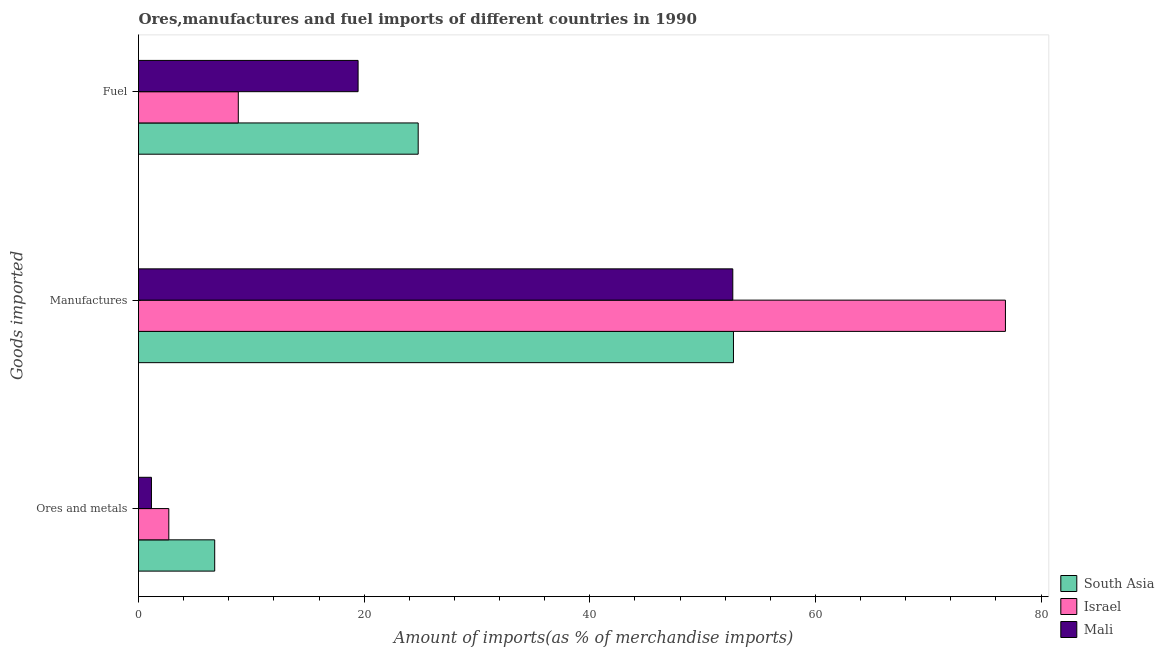How many different coloured bars are there?
Offer a terse response. 3. Are the number of bars on each tick of the Y-axis equal?
Provide a short and direct response. Yes. How many bars are there on the 1st tick from the top?
Your answer should be very brief. 3. What is the label of the 2nd group of bars from the top?
Provide a short and direct response. Manufactures. What is the percentage of manufactures imports in Israel?
Keep it short and to the point. 76.84. Across all countries, what is the maximum percentage of ores and metals imports?
Keep it short and to the point. 6.75. Across all countries, what is the minimum percentage of ores and metals imports?
Keep it short and to the point. 1.15. In which country was the percentage of ores and metals imports maximum?
Ensure brevity in your answer.  South Asia. What is the total percentage of ores and metals imports in the graph?
Give a very brief answer. 10.59. What is the difference between the percentage of manufactures imports in Mali and that in Israel?
Ensure brevity in your answer.  -24.17. What is the difference between the percentage of fuel imports in Mali and the percentage of manufactures imports in Israel?
Provide a short and direct response. -57.38. What is the average percentage of manufactures imports per country?
Your answer should be compact. 60.75. What is the difference between the percentage of ores and metals imports and percentage of manufactures imports in South Asia?
Your response must be concise. -45.98. What is the ratio of the percentage of fuel imports in Mali to that in Israel?
Give a very brief answer. 2.2. Is the percentage of manufactures imports in Mali less than that in South Asia?
Make the answer very short. Yes. What is the difference between the highest and the second highest percentage of ores and metals imports?
Your response must be concise. 4.07. What is the difference between the highest and the lowest percentage of ores and metals imports?
Your answer should be very brief. 5.61. In how many countries, is the percentage of fuel imports greater than the average percentage of fuel imports taken over all countries?
Provide a succinct answer. 2. What does the 1st bar from the bottom in Manufactures represents?
Ensure brevity in your answer.  South Asia. Is it the case that in every country, the sum of the percentage of ores and metals imports and percentage of manufactures imports is greater than the percentage of fuel imports?
Your answer should be compact. Yes. Are all the bars in the graph horizontal?
Make the answer very short. Yes. What is the difference between two consecutive major ticks on the X-axis?
Keep it short and to the point. 20. What is the title of the graph?
Offer a terse response. Ores,manufactures and fuel imports of different countries in 1990. What is the label or title of the X-axis?
Your answer should be compact. Amount of imports(as % of merchandise imports). What is the label or title of the Y-axis?
Provide a succinct answer. Goods imported. What is the Amount of imports(as % of merchandise imports) in South Asia in Ores and metals?
Make the answer very short. 6.75. What is the Amount of imports(as % of merchandise imports) of Israel in Ores and metals?
Your response must be concise. 2.69. What is the Amount of imports(as % of merchandise imports) in Mali in Ores and metals?
Provide a succinct answer. 1.15. What is the Amount of imports(as % of merchandise imports) in South Asia in Manufactures?
Give a very brief answer. 52.73. What is the Amount of imports(as % of merchandise imports) in Israel in Manufactures?
Give a very brief answer. 76.84. What is the Amount of imports(as % of merchandise imports) in Mali in Manufactures?
Give a very brief answer. 52.68. What is the Amount of imports(as % of merchandise imports) in South Asia in Fuel?
Give a very brief answer. 24.79. What is the Amount of imports(as % of merchandise imports) of Israel in Fuel?
Provide a short and direct response. 8.84. What is the Amount of imports(as % of merchandise imports) of Mali in Fuel?
Your answer should be compact. 19.46. Across all Goods imported, what is the maximum Amount of imports(as % of merchandise imports) of South Asia?
Keep it short and to the point. 52.73. Across all Goods imported, what is the maximum Amount of imports(as % of merchandise imports) in Israel?
Provide a succinct answer. 76.84. Across all Goods imported, what is the maximum Amount of imports(as % of merchandise imports) in Mali?
Your response must be concise. 52.68. Across all Goods imported, what is the minimum Amount of imports(as % of merchandise imports) of South Asia?
Your answer should be very brief. 6.75. Across all Goods imported, what is the minimum Amount of imports(as % of merchandise imports) in Israel?
Make the answer very short. 2.69. Across all Goods imported, what is the minimum Amount of imports(as % of merchandise imports) in Mali?
Your response must be concise. 1.15. What is the total Amount of imports(as % of merchandise imports) of South Asia in the graph?
Your response must be concise. 84.28. What is the total Amount of imports(as % of merchandise imports) in Israel in the graph?
Your response must be concise. 88.37. What is the total Amount of imports(as % of merchandise imports) in Mali in the graph?
Provide a succinct answer. 73.29. What is the difference between the Amount of imports(as % of merchandise imports) of South Asia in Ores and metals and that in Manufactures?
Your answer should be very brief. -45.98. What is the difference between the Amount of imports(as % of merchandise imports) of Israel in Ores and metals and that in Manufactures?
Your response must be concise. -74.16. What is the difference between the Amount of imports(as % of merchandise imports) in Mali in Ores and metals and that in Manufactures?
Your answer should be compact. -51.53. What is the difference between the Amount of imports(as % of merchandise imports) of South Asia in Ores and metals and that in Fuel?
Your answer should be compact. -18.04. What is the difference between the Amount of imports(as % of merchandise imports) in Israel in Ores and metals and that in Fuel?
Keep it short and to the point. -6.16. What is the difference between the Amount of imports(as % of merchandise imports) in Mali in Ores and metals and that in Fuel?
Ensure brevity in your answer.  -18.32. What is the difference between the Amount of imports(as % of merchandise imports) of South Asia in Manufactures and that in Fuel?
Provide a succinct answer. 27.95. What is the difference between the Amount of imports(as % of merchandise imports) of Israel in Manufactures and that in Fuel?
Keep it short and to the point. 68. What is the difference between the Amount of imports(as % of merchandise imports) of Mali in Manufactures and that in Fuel?
Make the answer very short. 33.21. What is the difference between the Amount of imports(as % of merchandise imports) of South Asia in Ores and metals and the Amount of imports(as % of merchandise imports) of Israel in Manufactures?
Ensure brevity in your answer.  -70.09. What is the difference between the Amount of imports(as % of merchandise imports) of South Asia in Ores and metals and the Amount of imports(as % of merchandise imports) of Mali in Manufactures?
Make the answer very short. -45.92. What is the difference between the Amount of imports(as % of merchandise imports) of Israel in Ores and metals and the Amount of imports(as % of merchandise imports) of Mali in Manufactures?
Provide a short and direct response. -49.99. What is the difference between the Amount of imports(as % of merchandise imports) of South Asia in Ores and metals and the Amount of imports(as % of merchandise imports) of Israel in Fuel?
Give a very brief answer. -2.09. What is the difference between the Amount of imports(as % of merchandise imports) in South Asia in Ores and metals and the Amount of imports(as % of merchandise imports) in Mali in Fuel?
Your response must be concise. -12.71. What is the difference between the Amount of imports(as % of merchandise imports) of Israel in Ores and metals and the Amount of imports(as % of merchandise imports) of Mali in Fuel?
Provide a short and direct response. -16.78. What is the difference between the Amount of imports(as % of merchandise imports) of South Asia in Manufactures and the Amount of imports(as % of merchandise imports) of Israel in Fuel?
Offer a terse response. 43.89. What is the difference between the Amount of imports(as % of merchandise imports) of South Asia in Manufactures and the Amount of imports(as % of merchandise imports) of Mali in Fuel?
Make the answer very short. 33.27. What is the difference between the Amount of imports(as % of merchandise imports) in Israel in Manufactures and the Amount of imports(as % of merchandise imports) in Mali in Fuel?
Your response must be concise. 57.38. What is the average Amount of imports(as % of merchandise imports) in South Asia per Goods imported?
Offer a very short reply. 28.09. What is the average Amount of imports(as % of merchandise imports) in Israel per Goods imported?
Your answer should be very brief. 29.46. What is the average Amount of imports(as % of merchandise imports) in Mali per Goods imported?
Your answer should be compact. 24.43. What is the difference between the Amount of imports(as % of merchandise imports) in South Asia and Amount of imports(as % of merchandise imports) in Israel in Ores and metals?
Give a very brief answer. 4.07. What is the difference between the Amount of imports(as % of merchandise imports) in South Asia and Amount of imports(as % of merchandise imports) in Mali in Ores and metals?
Provide a short and direct response. 5.61. What is the difference between the Amount of imports(as % of merchandise imports) of Israel and Amount of imports(as % of merchandise imports) of Mali in Ores and metals?
Your response must be concise. 1.54. What is the difference between the Amount of imports(as % of merchandise imports) in South Asia and Amount of imports(as % of merchandise imports) in Israel in Manufactures?
Make the answer very short. -24.11. What is the difference between the Amount of imports(as % of merchandise imports) in South Asia and Amount of imports(as % of merchandise imports) in Mali in Manufactures?
Provide a short and direct response. 0.06. What is the difference between the Amount of imports(as % of merchandise imports) in Israel and Amount of imports(as % of merchandise imports) in Mali in Manufactures?
Make the answer very short. 24.17. What is the difference between the Amount of imports(as % of merchandise imports) in South Asia and Amount of imports(as % of merchandise imports) in Israel in Fuel?
Ensure brevity in your answer.  15.94. What is the difference between the Amount of imports(as % of merchandise imports) of South Asia and Amount of imports(as % of merchandise imports) of Mali in Fuel?
Offer a very short reply. 5.33. What is the difference between the Amount of imports(as % of merchandise imports) in Israel and Amount of imports(as % of merchandise imports) in Mali in Fuel?
Make the answer very short. -10.62. What is the ratio of the Amount of imports(as % of merchandise imports) of South Asia in Ores and metals to that in Manufactures?
Provide a succinct answer. 0.13. What is the ratio of the Amount of imports(as % of merchandise imports) of Israel in Ores and metals to that in Manufactures?
Ensure brevity in your answer.  0.04. What is the ratio of the Amount of imports(as % of merchandise imports) of Mali in Ores and metals to that in Manufactures?
Ensure brevity in your answer.  0.02. What is the ratio of the Amount of imports(as % of merchandise imports) in South Asia in Ores and metals to that in Fuel?
Make the answer very short. 0.27. What is the ratio of the Amount of imports(as % of merchandise imports) of Israel in Ores and metals to that in Fuel?
Offer a very short reply. 0.3. What is the ratio of the Amount of imports(as % of merchandise imports) of Mali in Ores and metals to that in Fuel?
Your answer should be compact. 0.06. What is the ratio of the Amount of imports(as % of merchandise imports) of South Asia in Manufactures to that in Fuel?
Provide a short and direct response. 2.13. What is the ratio of the Amount of imports(as % of merchandise imports) of Israel in Manufactures to that in Fuel?
Provide a succinct answer. 8.69. What is the ratio of the Amount of imports(as % of merchandise imports) in Mali in Manufactures to that in Fuel?
Your answer should be compact. 2.71. What is the difference between the highest and the second highest Amount of imports(as % of merchandise imports) in South Asia?
Give a very brief answer. 27.95. What is the difference between the highest and the second highest Amount of imports(as % of merchandise imports) in Israel?
Offer a very short reply. 68. What is the difference between the highest and the second highest Amount of imports(as % of merchandise imports) in Mali?
Provide a short and direct response. 33.21. What is the difference between the highest and the lowest Amount of imports(as % of merchandise imports) in South Asia?
Make the answer very short. 45.98. What is the difference between the highest and the lowest Amount of imports(as % of merchandise imports) of Israel?
Keep it short and to the point. 74.16. What is the difference between the highest and the lowest Amount of imports(as % of merchandise imports) of Mali?
Your answer should be very brief. 51.53. 